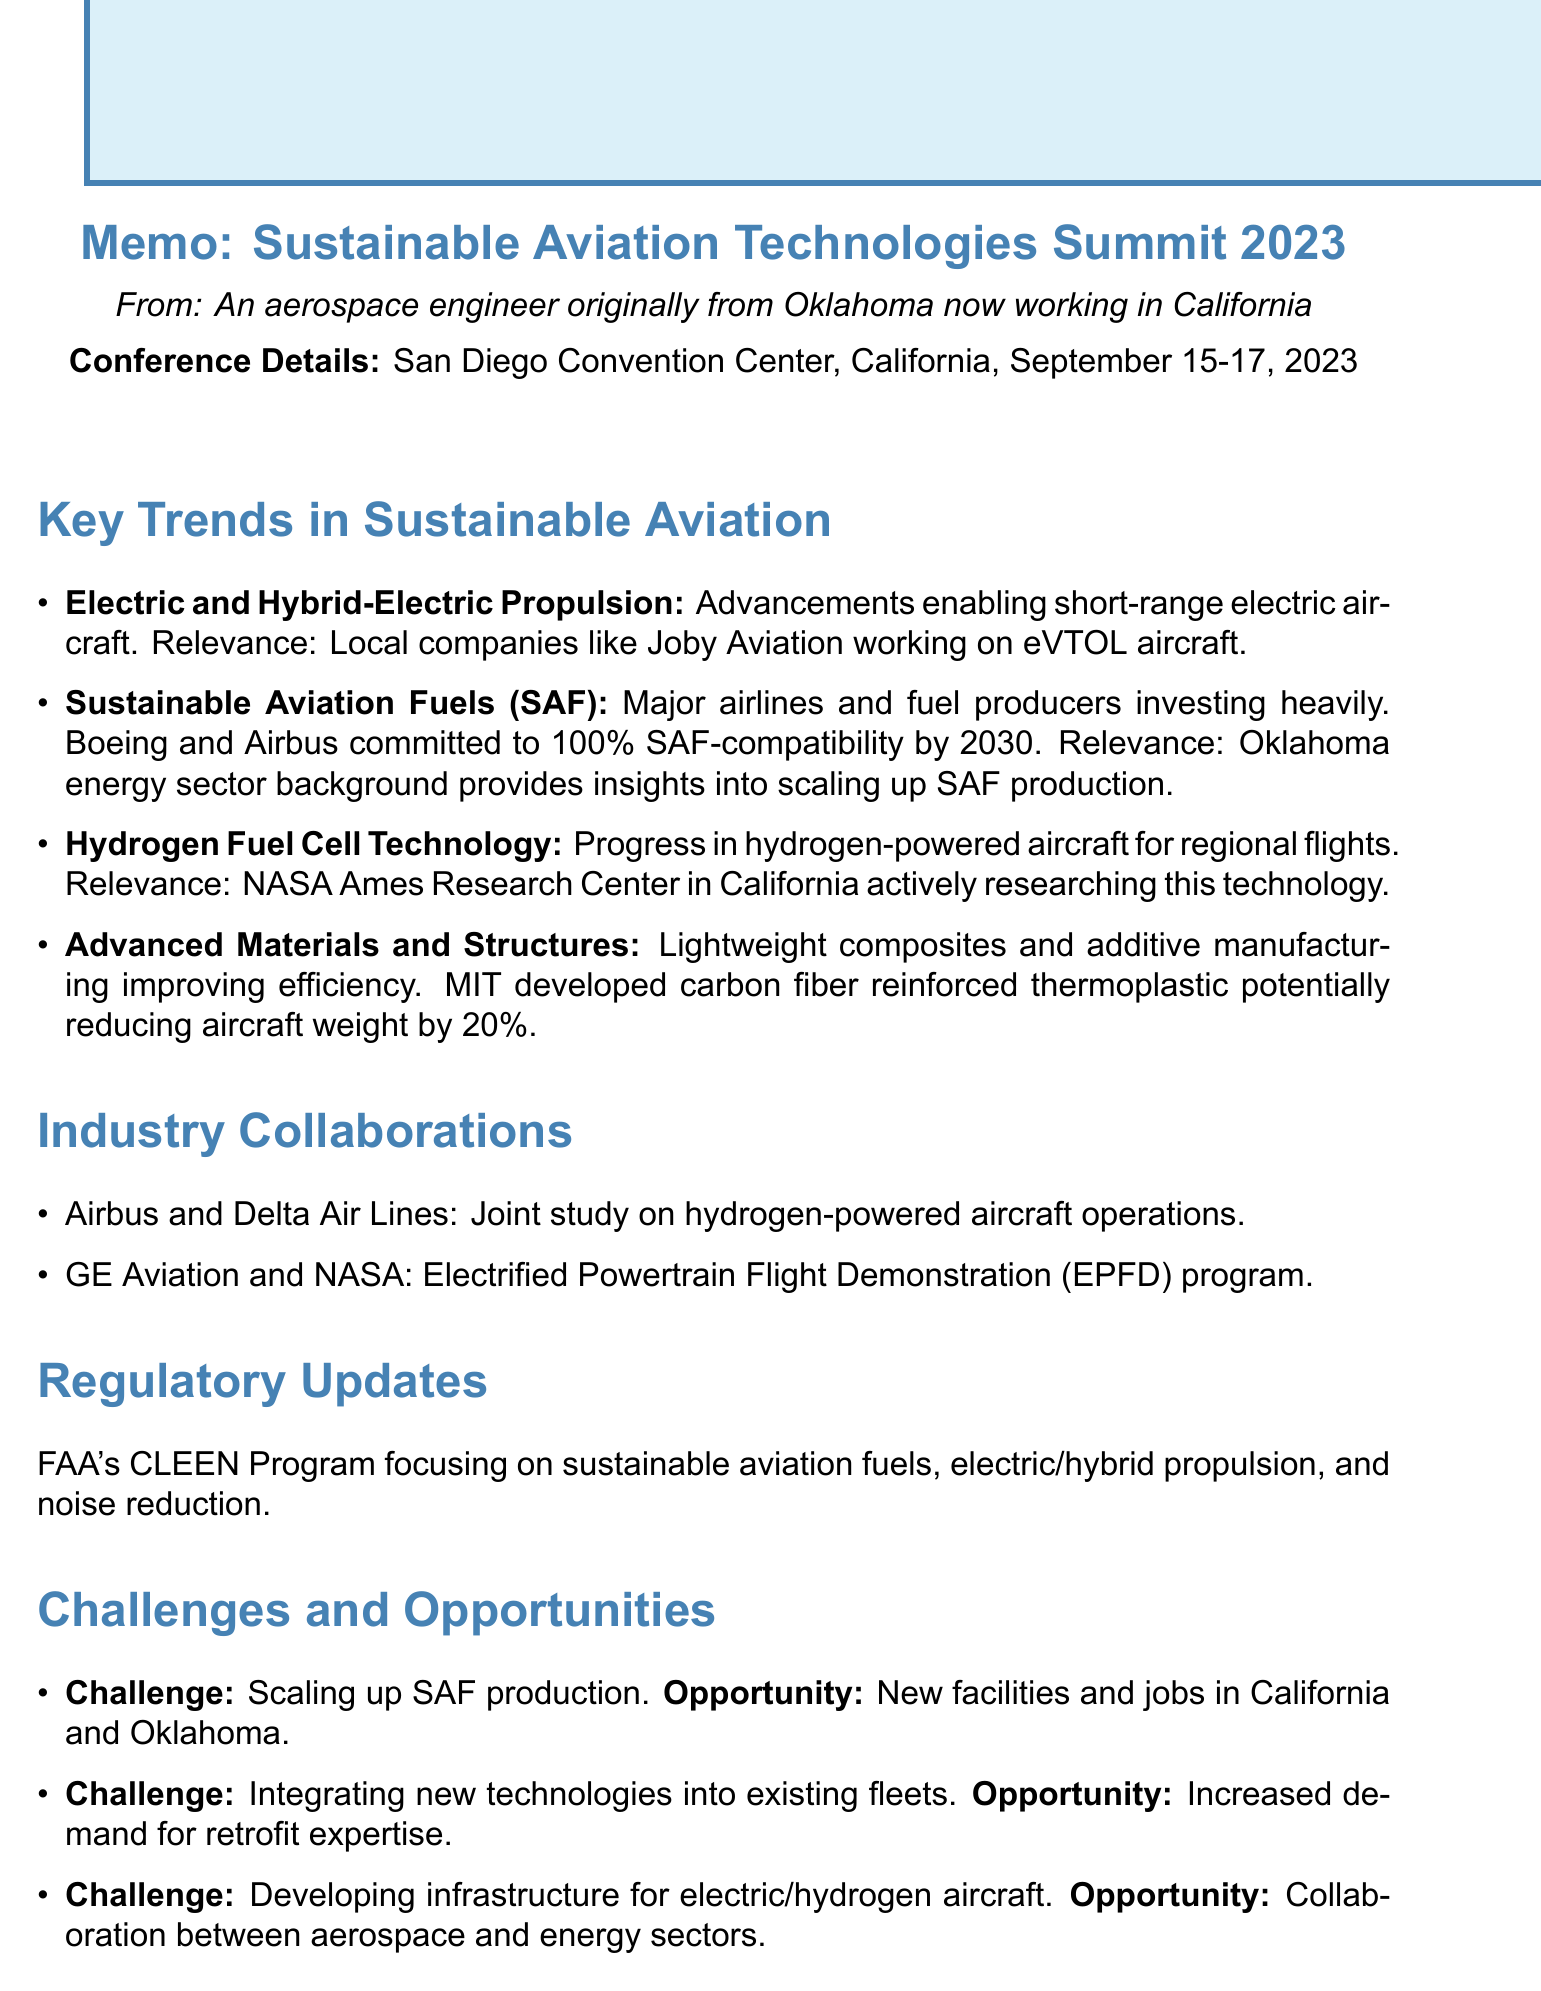What was the date of the conference? The date is mentioned in the document as September 15-17, 2023.
Answer: September 15-17, 2023 What is the location of the Sustainable Aviation Technologies Summit 2023? The location is specified in the document as the San Diego Convention Center, California.
Answer: San Diego Convention Center, California Which company is working on electric vertical takeoff and landing aircraft? The document mentions Joby Aviation as a local company working on eVTOL aircraft.
Answer: Joby Aviation What is the commitment of Boeing and Airbus regarding SAF compatibility? It states that they have committed to making their aircraft 100% SAF-compatible by 2030.
Answer: 100% SAF-compatible by 2030 What is the focus of the FAA's CLEEN Program? The focus areas listed include sustainable aviation fuels, electric and hybrid-electric propulsion, and noise reduction technologies.
Answer: Sustainable aviation fuels, electric and hybrid-electric propulsion, noise reduction technologies What is a challenge mentioned regarding sustainable aviation fuel production? The document states the challenge as scaling up sustainable aviation fuel production.
Answer: Scaling up sustainable aviation fuel production What potential opportunity is associated with developing infrastructure for electric and hydrogen aircraft? The opportunity related to this is collaboration between aerospace and energy sectors to create innovative solutions.
Answer: Collaboration between aerospace and energy sectors What project is the partnership between Airbus and Delta Air Lines focused on? The document details that they are conducting a joint study on hydrogen-powered aircraft operations.
Answer: Joint study on hydrogen-powered aircraft operations What technological advancement is expected to reduce aircraft weight by up to 20%? The document mentions the development of a new carbon fiber reinforced thermoplastic material by MIT as the expected advancement.
Answer: New carbon fiber reinforced thermoplastic material 